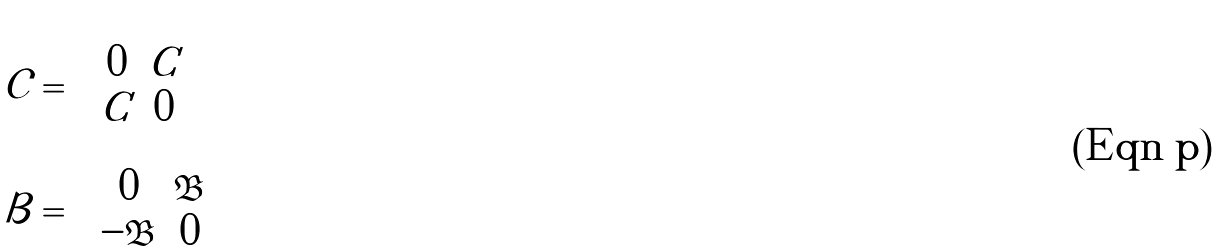Convert formula to latex. <formula><loc_0><loc_0><loc_500><loc_500>\mathcal { C } = & \left ( \begin{array} { c c } 0 & C \\ C & 0 \end{array} \right ) \\ \mathcal { B } = & \left ( \begin{array} { c c } 0 & \mathfrak { B } \\ - \mathfrak { B } & 0 \end{array} \right )</formula> 